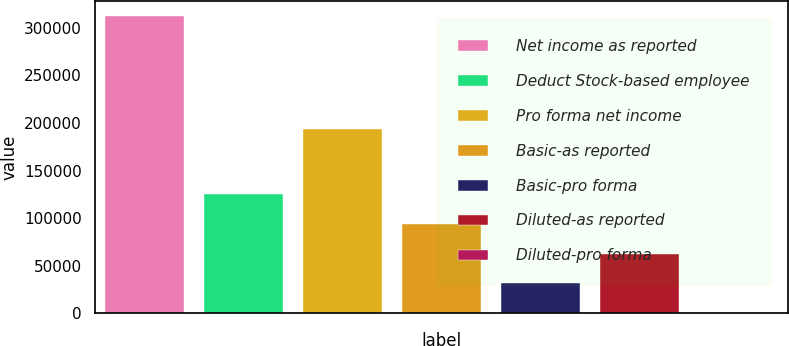<chart> <loc_0><loc_0><loc_500><loc_500><bar_chart><fcel>Net income as reported<fcel>Deduct Stock-based employee<fcel>Pro forma net income<fcel>Basic-as reported<fcel>Basic-pro forma<fcel>Diluted-as reported<fcel>Diluted-pro forma<nl><fcel>312723<fcel>125090<fcel>193486<fcel>93817.3<fcel>31272.8<fcel>62545<fcel>0.54<nl></chart> 